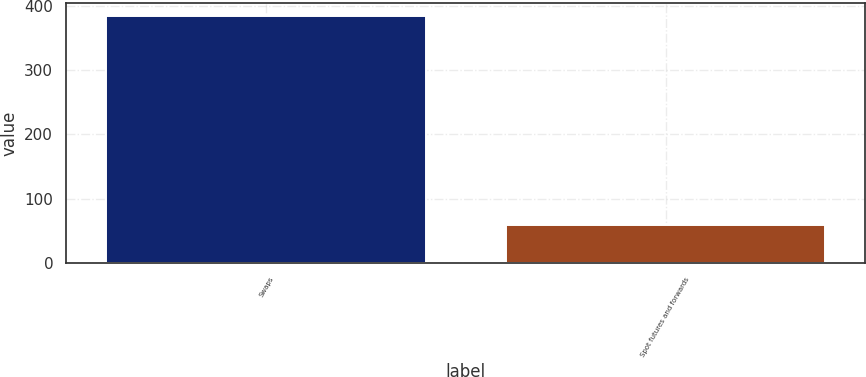Convert chart to OTSL. <chart><loc_0><loc_0><loc_500><loc_500><bar_chart><fcel>Swaps<fcel>Spot futures and forwards<nl><fcel>385<fcel>58.8<nl></chart> 